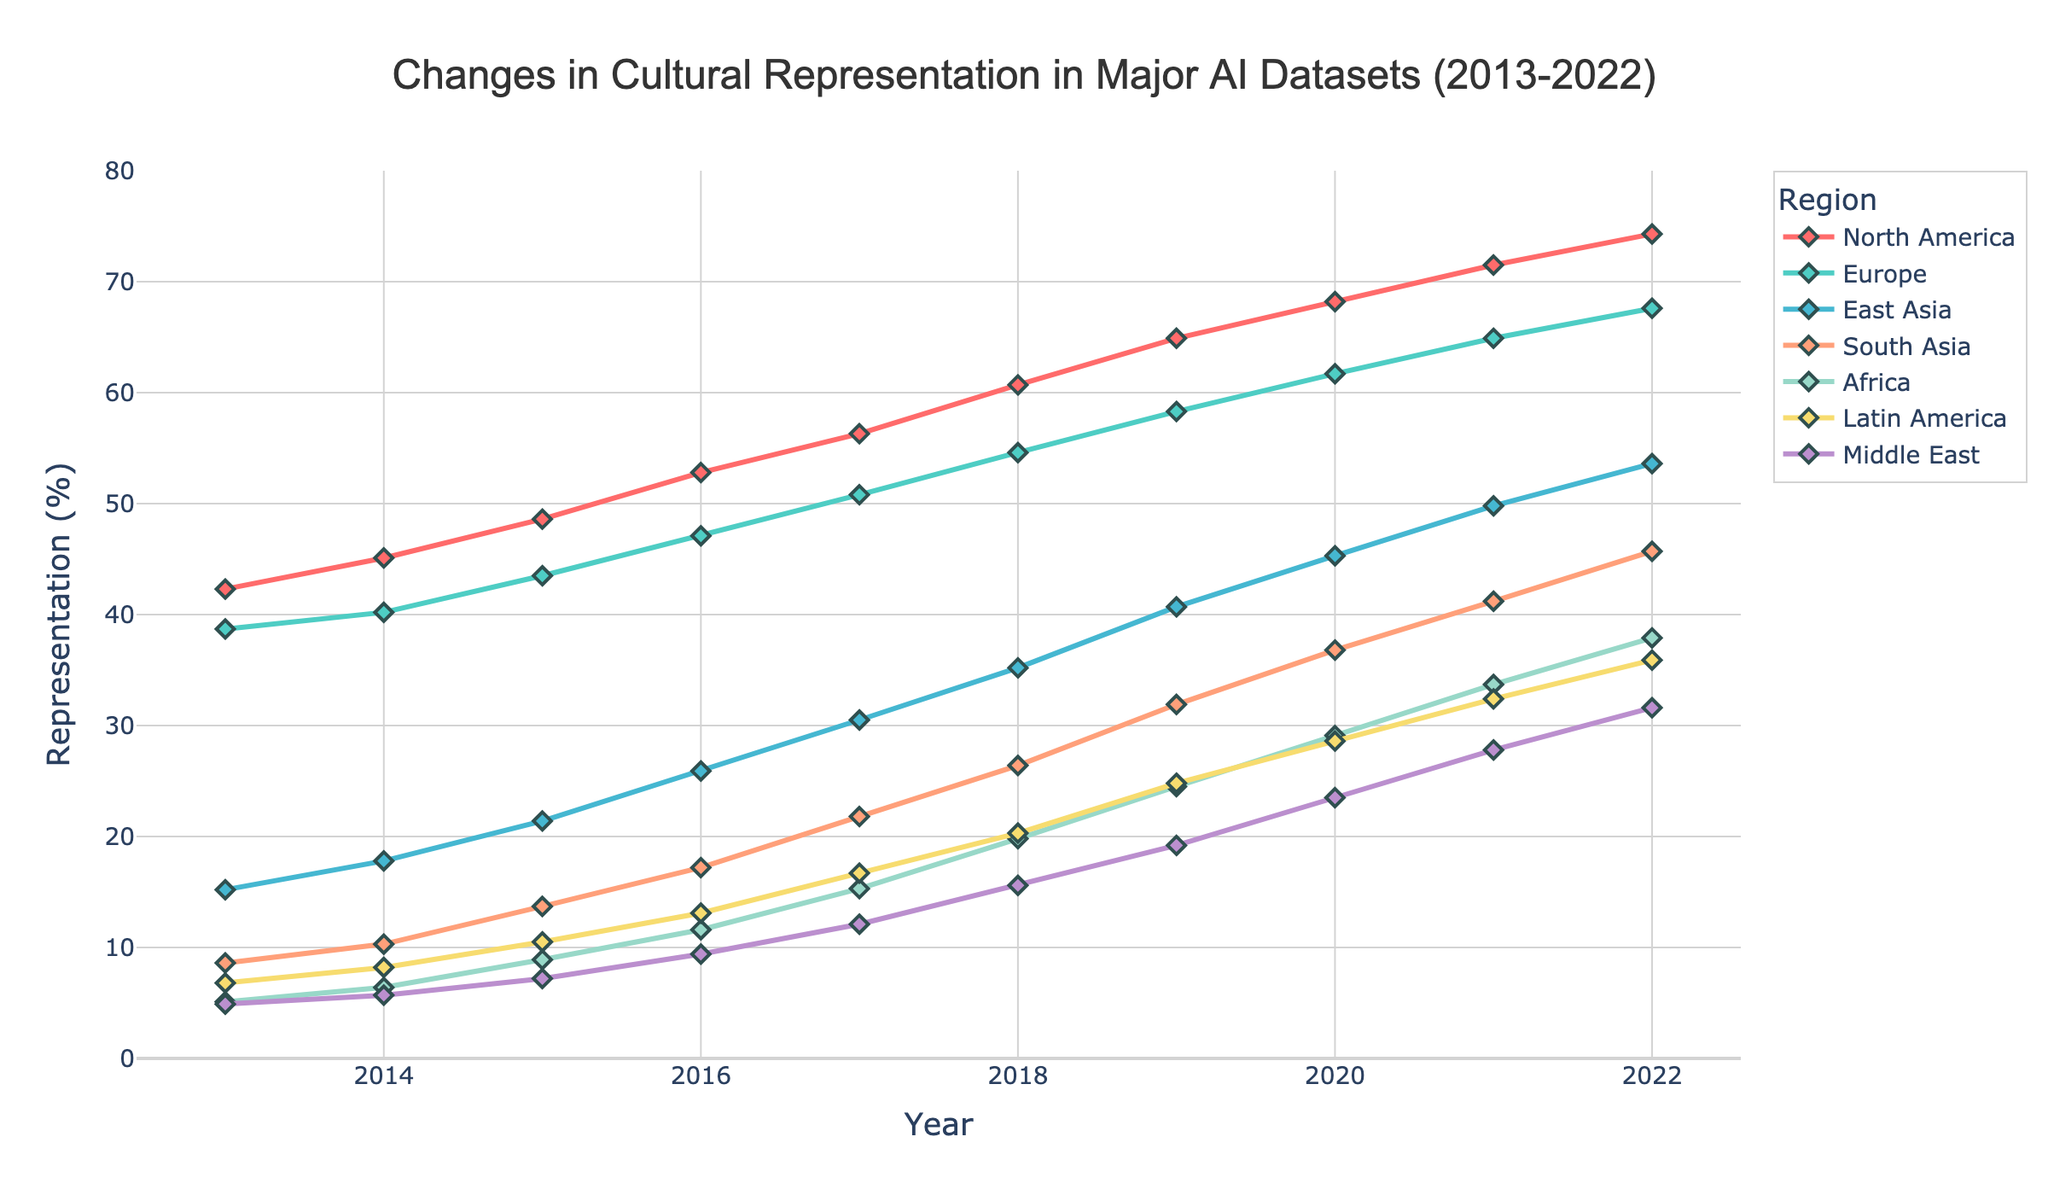What region showed the highest increase in representation from 2013 to 2022? To find this, we subtract the representation values for 2013 from 2022 for each region and identify the highest difference. North America shows the highest increase: 74.3% (2022) - 42.3% (2013) = 32.0%.
Answer: North America Which region had the lowest representation in 2022? Looking at the end points of the lines, the Middle East had the lowest representation in 2022 at 31.6%.
Answer: Middle East Between 2016 and 2018, which region saw the largest absolute growth in representation? Calculate the difference in representation for each region between 2016 and 2018. North America: 60.7% - 52.8% = 7.9%, Europe: 54.6% - 47.1% = 7.5%, East Asia: 35.2% - 25.9% = 9.3%, South Asia: 26.4% - 17.2% = 9.2%, Africa: 19.8% - 11.6% = 8.2%, Latin America: 20.3% - 13.1% = 7.2%, Middle East: 15.6% - 9.4% = 6.2%. East Asia saw the largest absolute growth with 9.3%.
Answer: East Asia In 2015, which two regions had the closest representation percentages and what were they? Looking at the data for 2015, compare the values to find the smallest difference. Latin America (10.5%) and Middle East (7.2%) were the closest regions; the difference is 10.5% - 7.2% = 3.3%.
Answer: Latin America, Middle East What was the average representation of South Asia over the decade? Sum the representation values of South Asia from 2013 to 2022, then divide by the number of years. (8.6 + 10.3 + 13.7 + 17.2 + 21.8 + 26.4 + 31.9 + 36.8 + 41.2 + 45.7) / 10 = 25.36%.
Answer: 25.36% Which regions had a steady (uninterrupted) increase in representation every year? Examine each region's line to ensure the values increase each year without any drops. North America, Europe, East Asia, South Asia, Africa, Latin America, and the Middle East all show a steady increase.
Answer: All regions In terms of percentage points, how much more was the representation of Europe compared to Africa in 2020? Subtract the percentage of Africa from Europe for 2020. Europe: 61.7%, Africa: 29.1%. Therefore, 61.7% - 29.1% = 32.6%.
Answer: 32.6% How did the representation of Latin America change from 2015 to 2022? Subtract the representation of Latin America in 2015 from its representation in 2022: 35.9% - 10.5% = 25.4%.
Answer: Increased by 25.4% Which region had the second-highest representation in 2017? Refer to the data for 2017. North America had the highest (56.3%), followed by Europe (50.8%).
Answer: Europe 